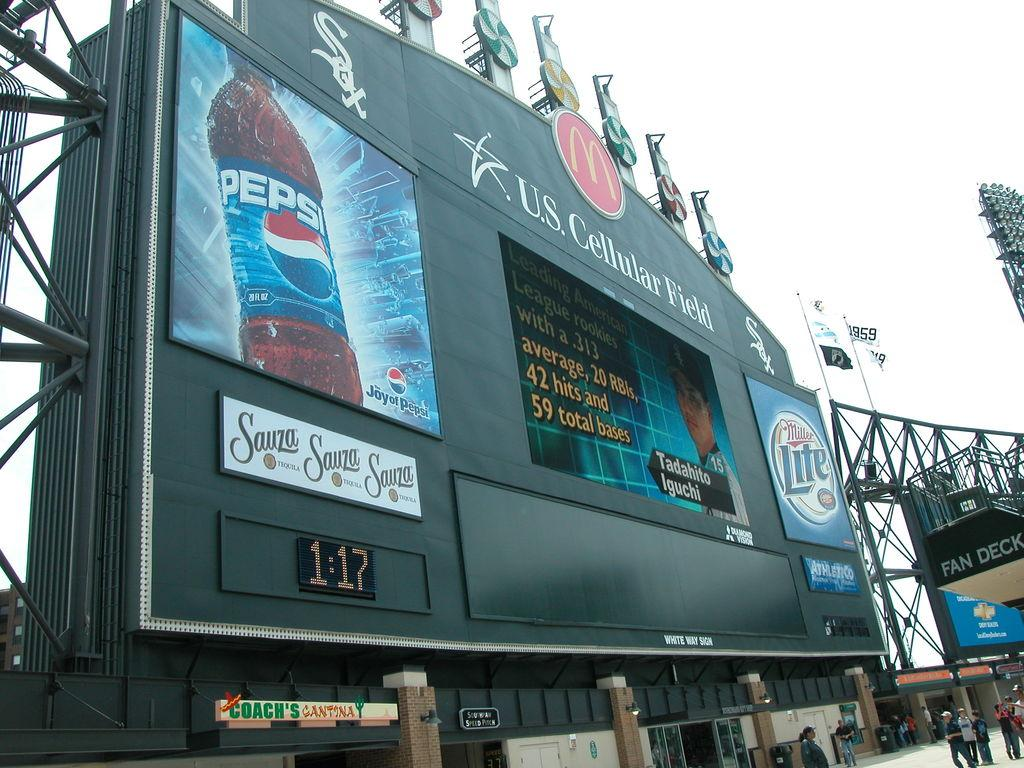Provide a one-sentence caption for the provided image. An advertisement on the U.S Cellular Field displaying an ad for Pepsi. 